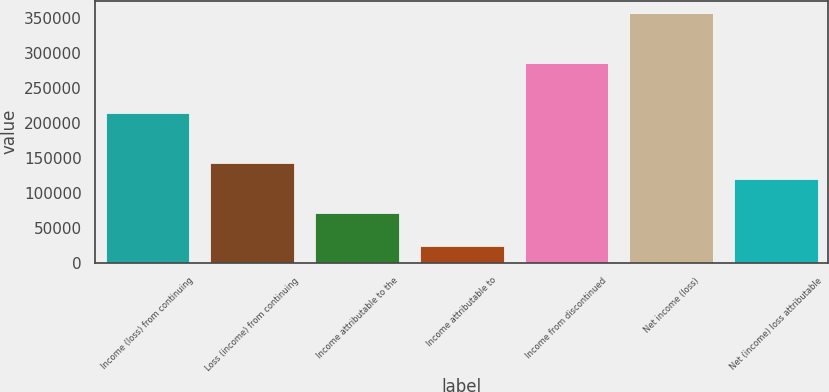<chart> <loc_0><loc_0><loc_500><loc_500><bar_chart><fcel>Income (loss) from continuing<fcel>Loss (income) from continuing<fcel>Income attributable to the<fcel>Income attributable to<fcel>Income from discontinued<fcel>Net income (loss)<fcel>Net (income) loss attributable<nl><fcel>214043<fcel>142695<fcel>71348.2<fcel>23783.4<fcel>285390<fcel>356737<fcel>118913<nl></chart> 